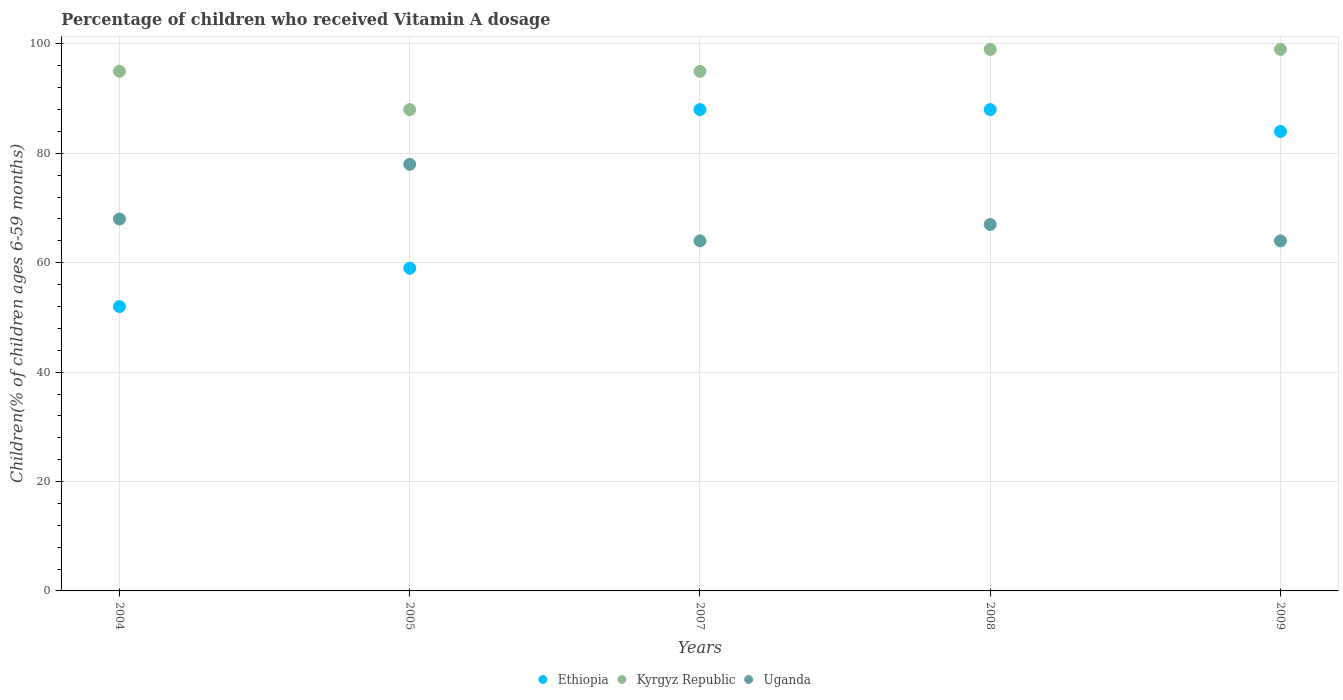How many different coloured dotlines are there?
Your answer should be very brief. 3. Is the number of dotlines equal to the number of legend labels?
Your response must be concise. Yes. What is the percentage of children who received Vitamin A dosage in Kyrgyz Republic in 2007?
Provide a short and direct response. 95. Across all years, what is the maximum percentage of children who received Vitamin A dosage in Ethiopia?
Provide a succinct answer. 88. Across all years, what is the minimum percentage of children who received Vitamin A dosage in Uganda?
Provide a succinct answer. 64. What is the total percentage of children who received Vitamin A dosage in Ethiopia in the graph?
Provide a succinct answer. 371. What is the difference between the percentage of children who received Vitamin A dosage in Ethiopia in 2005 and that in 2009?
Provide a short and direct response. -25. What is the average percentage of children who received Vitamin A dosage in Kyrgyz Republic per year?
Your answer should be compact. 95.2. In how many years, is the percentage of children who received Vitamin A dosage in Kyrgyz Republic greater than 52 %?
Your answer should be very brief. 5. What is the ratio of the percentage of children who received Vitamin A dosage in Kyrgyz Republic in 2004 to that in 2005?
Your answer should be very brief. 1.08. What is the difference between the highest and the second highest percentage of children who received Vitamin A dosage in Ethiopia?
Provide a succinct answer. 0. What is the difference between the highest and the lowest percentage of children who received Vitamin A dosage in Ethiopia?
Provide a succinct answer. 36. Is it the case that in every year, the sum of the percentage of children who received Vitamin A dosage in Kyrgyz Republic and percentage of children who received Vitamin A dosage in Ethiopia  is greater than the percentage of children who received Vitamin A dosage in Uganda?
Offer a very short reply. Yes. Is the percentage of children who received Vitamin A dosage in Uganda strictly less than the percentage of children who received Vitamin A dosage in Kyrgyz Republic over the years?
Make the answer very short. Yes. How many years are there in the graph?
Your answer should be very brief. 5. Where does the legend appear in the graph?
Your response must be concise. Bottom center. How many legend labels are there?
Offer a very short reply. 3. How are the legend labels stacked?
Offer a very short reply. Horizontal. What is the title of the graph?
Provide a short and direct response. Percentage of children who received Vitamin A dosage. Does "Portugal" appear as one of the legend labels in the graph?
Provide a short and direct response. No. What is the label or title of the X-axis?
Your response must be concise. Years. What is the label or title of the Y-axis?
Make the answer very short. Children(% of children ages 6-59 months). What is the Children(% of children ages 6-59 months) of Uganda in 2004?
Your answer should be very brief. 68. What is the Children(% of children ages 6-59 months) of Ethiopia in 2005?
Your answer should be compact. 59. What is the Children(% of children ages 6-59 months) of Kyrgyz Republic in 2007?
Keep it short and to the point. 95. What is the Children(% of children ages 6-59 months) in Uganda in 2007?
Ensure brevity in your answer.  64. What is the Children(% of children ages 6-59 months) of Kyrgyz Republic in 2008?
Offer a terse response. 99. What is the Children(% of children ages 6-59 months) in Ethiopia in 2009?
Offer a very short reply. 84. What is the Children(% of children ages 6-59 months) of Uganda in 2009?
Your answer should be compact. 64. Across all years, what is the maximum Children(% of children ages 6-59 months) in Uganda?
Ensure brevity in your answer.  78. Across all years, what is the minimum Children(% of children ages 6-59 months) of Uganda?
Keep it short and to the point. 64. What is the total Children(% of children ages 6-59 months) of Ethiopia in the graph?
Provide a short and direct response. 371. What is the total Children(% of children ages 6-59 months) in Kyrgyz Republic in the graph?
Make the answer very short. 476. What is the total Children(% of children ages 6-59 months) in Uganda in the graph?
Offer a terse response. 341. What is the difference between the Children(% of children ages 6-59 months) in Ethiopia in 2004 and that in 2007?
Provide a succinct answer. -36. What is the difference between the Children(% of children ages 6-59 months) in Uganda in 2004 and that in 2007?
Offer a very short reply. 4. What is the difference between the Children(% of children ages 6-59 months) in Ethiopia in 2004 and that in 2008?
Your answer should be compact. -36. What is the difference between the Children(% of children ages 6-59 months) in Kyrgyz Republic in 2004 and that in 2008?
Your response must be concise. -4. What is the difference between the Children(% of children ages 6-59 months) in Uganda in 2004 and that in 2008?
Ensure brevity in your answer.  1. What is the difference between the Children(% of children ages 6-59 months) in Ethiopia in 2004 and that in 2009?
Give a very brief answer. -32. What is the difference between the Children(% of children ages 6-59 months) in Uganda in 2004 and that in 2009?
Offer a terse response. 4. What is the difference between the Children(% of children ages 6-59 months) of Uganda in 2005 and that in 2007?
Offer a very short reply. 14. What is the difference between the Children(% of children ages 6-59 months) of Ethiopia in 2005 and that in 2009?
Keep it short and to the point. -25. What is the difference between the Children(% of children ages 6-59 months) of Ethiopia in 2007 and that in 2008?
Provide a short and direct response. 0. What is the difference between the Children(% of children ages 6-59 months) of Kyrgyz Republic in 2007 and that in 2008?
Provide a succinct answer. -4. What is the difference between the Children(% of children ages 6-59 months) in Ethiopia in 2007 and that in 2009?
Your answer should be very brief. 4. What is the difference between the Children(% of children ages 6-59 months) of Kyrgyz Republic in 2007 and that in 2009?
Provide a succinct answer. -4. What is the difference between the Children(% of children ages 6-59 months) in Kyrgyz Republic in 2008 and that in 2009?
Provide a succinct answer. 0. What is the difference between the Children(% of children ages 6-59 months) in Ethiopia in 2004 and the Children(% of children ages 6-59 months) in Kyrgyz Republic in 2005?
Provide a short and direct response. -36. What is the difference between the Children(% of children ages 6-59 months) of Ethiopia in 2004 and the Children(% of children ages 6-59 months) of Uganda in 2005?
Ensure brevity in your answer.  -26. What is the difference between the Children(% of children ages 6-59 months) in Kyrgyz Republic in 2004 and the Children(% of children ages 6-59 months) in Uganda in 2005?
Offer a very short reply. 17. What is the difference between the Children(% of children ages 6-59 months) of Ethiopia in 2004 and the Children(% of children ages 6-59 months) of Kyrgyz Republic in 2007?
Your answer should be very brief. -43. What is the difference between the Children(% of children ages 6-59 months) in Kyrgyz Republic in 2004 and the Children(% of children ages 6-59 months) in Uganda in 2007?
Your answer should be compact. 31. What is the difference between the Children(% of children ages 6-59 months) in Ethiopia in 2004 and the Children(% of children ages 6-59 months) in Kyrgyz Republic in 2008?
Give a very brief answer. -47. What is the difference between the Children(% of children ages 6-59 months) in Kyrgyz Republic in 2004 and the Children(% of children ages 6-59 months) in Uganda in 2008?
Provide a succinct answer. 28. What is the difference between the Children(% of children ages 6-59 months) of Ethiopia in 2004 and the Children(% of children ages 6-59 months) of Kyrgyz Republic in 2009?
Provide a succinct answer. -47. What is the difference between the Children(% of children ages 6-59 months) of Ethiopia in 2005 and the Children(% of children ages 6-59 months) of Kyrgyz Republic in 2007?
Keep it short and to the point. -36. What is the difference between the Children(% of children ages 6-59 months) of Ethiopia in 2005 and the Children(% of children ages 6-59 months) of Uganda in 2007?
Provide a succinct answer. -5. What is the difference between the Children(% of children ages 6-59 months) in Kyrgyz Republic in 2005 and the Children(% of children ages 6-59 months) in Uganda in 2007?
Keep it short and to the point. 24. What is the difference between the Children(% of children ages 6-59 months) of Ethiopia in 2005 and the Children(% of children ages 6-59 months) of Kyrgyz Republic in 2008?
Keep it short and to the point. -40. What is the difference between the Children(% of children ages 6-59 months) in Kyrgyz Republic in 2005 and the Children(% of children ages 6-59 months) in Uganda in 2008?
Your answer should be compact. 21. What is the difference between the Children(% of children ages 6-59 months) of Ethiopia in 2005 and the Children(% of children ages 6-59 months) of Uganda in 2009?
Make the answer very short. -5. What is the difference between the Children(% of children ages 6-59 months) of Ethiopia in 2007 and the Children(% of children ages 6-59 months) of Uganda in 2008?
Provide a short and direct response. 21. What is the difference between the Children(% of children ages 6-59 months) of Kyrgyz Republic in 2007 and the Children(% of children ages 6-59 months) of Uganda in 2009?
Offer a terse response. 31. What is the difference between the Children(% of children ages 6-59 months) in Kyrgyz Republic in 2008 and the Children(% of children ages 6-59 months) in Uganda in 2009?
Offer a terse response. 35. What is the average Children(% of children ages 6-59 months) of Ethiopia per year?
Keep it short and to the point. 74.2. What is the average Children(% of children ages 6-59 months) in Kyrgyz Republic per year?
Give a very brief answer. 95.2. What is the average Children(% of children ages 6-59 months) of Uganda per year?
Provide a succinct answer. 68.2. In the year 2004, what is the difference between the Children(% of children ages 6-59 months) of Ethiopia and Children(% of children ages 6-59 months) of Kyrgyz Republic?
Keep it short and to the point. -43. In the year 2004, what is the difference between the Children(% of children ages 6-59 months) in Kyrgyz Republic and Children(% of children ages 6-59 months) in Uganda?
Keep it short and to the point. 27. In the year 2007, what is the difference between the Children(% of children ages 6-59 months) of Ethiopia and Children(% of children ages 6-59 months) of Uganda?
Your response must be concise. 24. In the year 2007, what is the difference between the Children(% of children ages 6-59 months) in Kyrgyz Republic and Children(% of children ages 6-59 months) in Uganda?
Ensure brevity in your answer.  31. In the year 2008, what is the difference between the Children(% of children ages 6-59 months) in Ethiopia and Children(% of children ages 6-59 months) in Kyrgyz Republic?
Provide a succinct answer. -11. In the year 2008, what is the difference between the Children(% of children ages 6-59 months) in Ethiopia and Children(% of children ages 6-59 months) in Uganda?
Give a very brief answer. 21. In the year 2008, what is the difference between the Children(% of children ages 6-59 months) of Kyrgyz Republic and Children(% of children ages 6-59 months) of Uganda?
Give a very brief answer. 32. In the year 2009, what is the difference between the Children(% of children ages 6-59 months) of Ethiopia and Children(% of children ages 6-59 months) of Uganda?
Provide a short and direct response. 20. In the year 2009, what is the difference between the Children(% of children ages 6-59 months) of Kyrgyz Republic and Children(% of children ages 6-59 months) of Uganda?
Give a very brief answer. 35. What is the ratio of the Children(% of children ages 6-59 months) in Ethiopia in 2004 to that in 2005?
Provide a short and direct response. 0.88. What is the ratio of the Children(% of children ages 6-59 months) of Kyrgyz Republic in 2004 to that in 2005?
Ensure brevity in your answer.  1.08. What is the ratio of the Children(% of children ages 6-59 months) of Uganda in 2004 to that in 2005?
Keep it short and to the point. 0.87. What is the ratio of the Children(% of children ages 6-59 months) in Ethiopia in 2004 to that in 2007?
Ensure brevity in your answer.  0.59. What is the ratio of the Children(% of children ages 6-59 months) in Ethiopia in 2004 to that in 2008?
Ensure brevity in your answer.  0.59. What is the ratio of the Children(% of children ages 6-59 months) of Kyrgyz Republic in 2004 to that in 2008?
Keep it short and to the point. 0.96. What is the ratio of the Children(% of children ages 6-59 months) of Uganda in 2004 to that in 2008?
Keep it short and to the point. 1.01. What is the ratio of the Children(% of children ages 6-59 months) in Ethiopia in 2004 to that in 2009?
Your response must be concise. 0.62. What is the ratio of the Children(% of children ages 6-59 months) in Kyrgyz Republic in 2004 to that in 2009?
Your answer should be compact. 0.96. What is the ratio of the Children(% of children ages 6-59 months) in Uganda in 2004 to that in 2009?
Offer a very short reply. 1.06. What is the ratio of the Children(% of children ages 6-59 months) of Ethiopia in 2005 to that in 2007?
Provide a succinct answer. 0.67. What is the ratio of the Children(% of children ages 6-59 months) of Kyrgyz Republic in 2005 to that in 2007?
Offer a very short reply. 0.93. What is the ratio of the Children(% of children ages 6-59 months) in Uganda in 2005 to that in 2007?
Your answer should be very brief. 1.22. What is the ratio of the Children(% of children ages 6-59 months) of Ethiopia in 2005 to that in 2008?
Give a very brief answer. 0.67. What is the ratio of the Children(% of children ages 6-59 months) of Kyrgyz Republic in 2005 to that in 2008?
Your response must be concise. 0.89. What is the ratio of the Children(% of children ages 6-59 months) of Uganda in 2005 to that in 2008?
Offer a terse response. 1.16. What is the ratio of the Children(% of children ages 6-59 months) of Ethiopia in 2005 to that in 2009?
Your answer should be very brief. 0.7. What is the ratio of the Children(% of children ages 6-59 months) in Kyrgyz Republic in 2005 to that in 2009?
Offer a very short reply. 0.89. What is the ratio of the Children(% of children ages 6-59 months) in Uganda in 2005 to that in 2009?
Give a very brief answer. 1.22. What is the ratio of the Children(% of children ages 6-59 months) of Kyrgyz Republic in 2007 to that in 2008?
Provide a short and direct response. 0.96. What is the ratio of the Children(% of children ages 6-59 months) in Uganda in 2007 to that in 2008?
Ensure brevity in your answer.  0.96. What is the ratio of the Children(% of children ages 6-59 months) in Ethiopia in 2007 to that in 2009?
Provide a succinct answer. 1.05. What is the ratio of the Children(% of children ages 6-59 months) in Kyrgyz Republic in 2007 to that in 2009?
Keep it short and to the point. 0.96. What is the ratio of the Children(% of children ages 6-59 months) of Ethiopia in 2008 to that in 2009?
Offer a terse response. 1.05. What is the ratio of the Children(% of children ages 6-59 months) of Kyrgyz Republic in 2008 to that in 2009?
Keep it short and to the point. 1. What is the ratio of the Children(% of children ages 6-59 months) of Uganda in 2008 to that in 2009?
Provide a succinct answer. 1.05. What is the difference between the highest and the second highest Children(% of children ages 6-59 months) of Kyrgyz Republic?
Ensure brevity in your answer.  0. What is the difference between the highest and the second highest Children(% of children ages 6-59 months) in Uganda?
Offer a terse response. 10. 